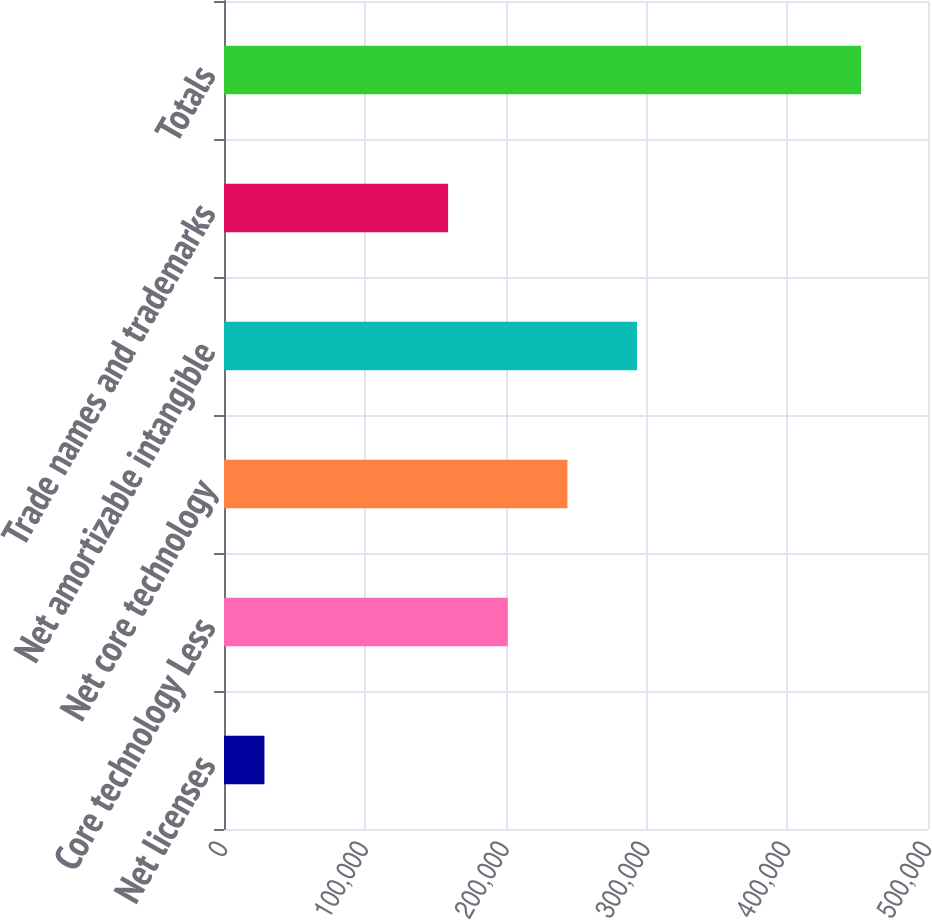Convert chart to OTSL. <chart><loc_0><loc_0><loc_500><loc_500><bar_chart><fcel>Net licenses<fcel>Core technology Less<fcel>Net core technology<fcel>Net amortizable intangible<fcel>Trade names and trademarks<fcel>Totals<nl><fcel>28725<fcel>201540<fcel>243915<fcel>293308<fcel>159165<fcel>452473<nl></chart> 